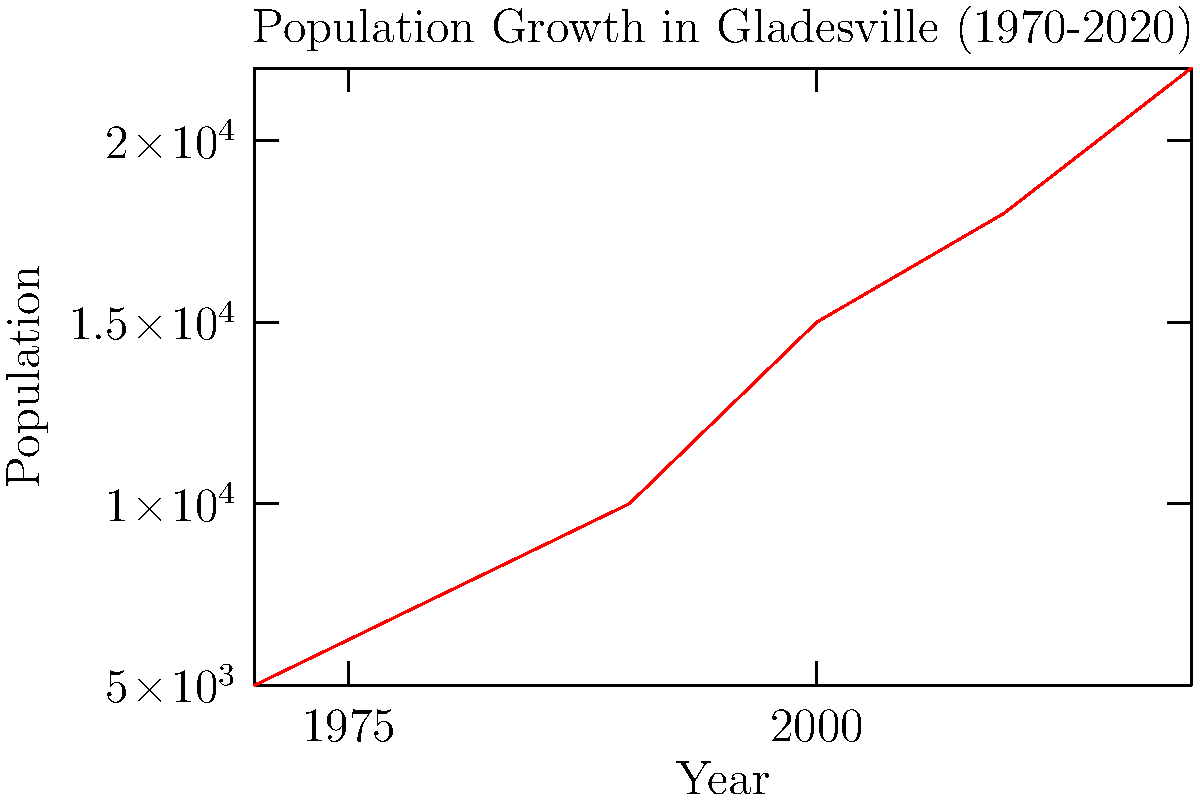Based on the line graph showing Gladesville's population growth from 1970 to 2020, what was the approximate increase in population between 1990 and 2000? To determine the population increase between 1990 and 2000:

1. Locate the population value for 1990 on the y-axis: approximately 10,000
2. Locate the population value for 2000 on the y-axis: approximately 15,000
3. Calculate the difference:
   $15,000 - 10,000 = 5,000$

The population increased by about 5,000 people between 1990 and 2000.

This significant growth might be of particular interest to an elder resident concerned about community life quality and historical conservation, as rapid population increases can put pressure on local infrastructure and potentially threaten historical areas.
Answer: 5,000 